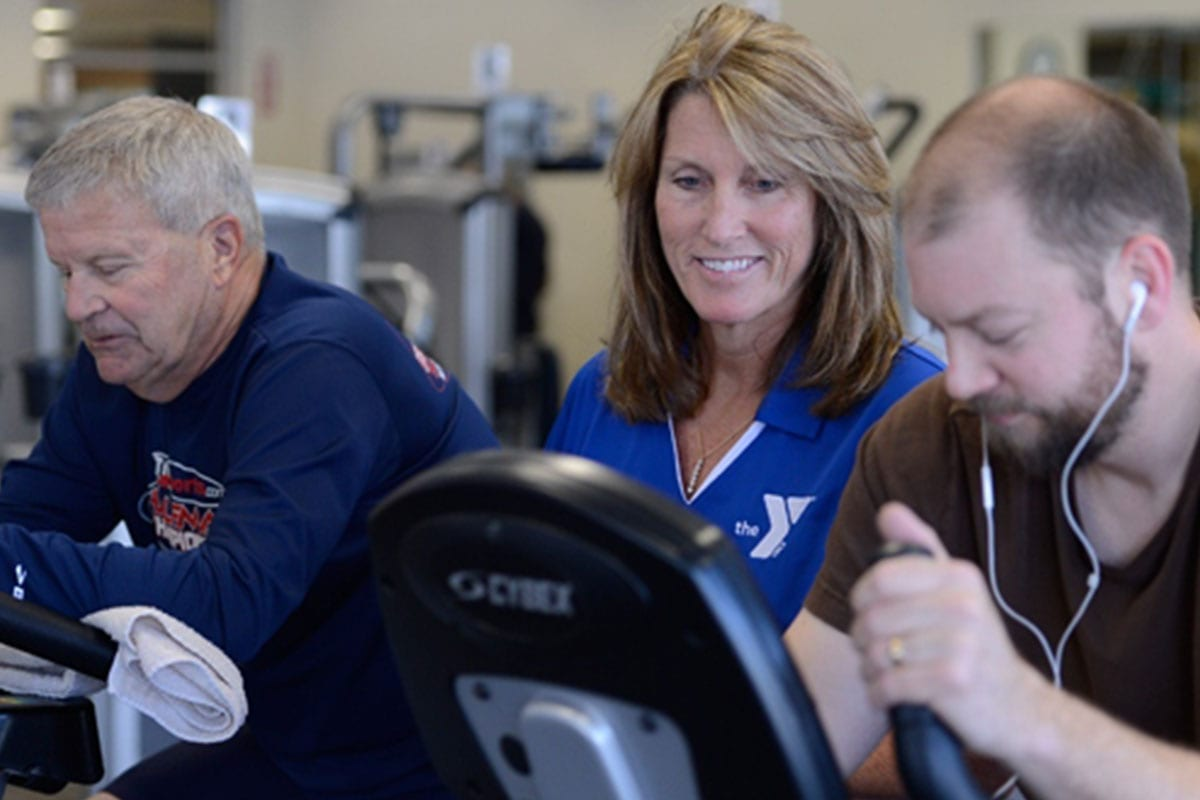Can you describe a scenario where the instructor plays a crucial role in enhancing the experience for a new member? For a new member, the instructor could play a crucial role by providing a warm and friendly welcome, making them feel comfortable and included. She might start with an introductory session, explaining how to use the various equipment safely and effectively. The instructor could also conduct a fitness assessment to understand their fitness level and goals, and then create a personalized workout plan for them. Throughout the session, she would offer encouragement, correct their form, and provide tips to maximize the benefits of each exercise. By fostering a supportive and informative environment, the instructor helps the new member build confidence and establishes a positive workout experience, which can be pivotal in their long-term commitment to the fitness program. 